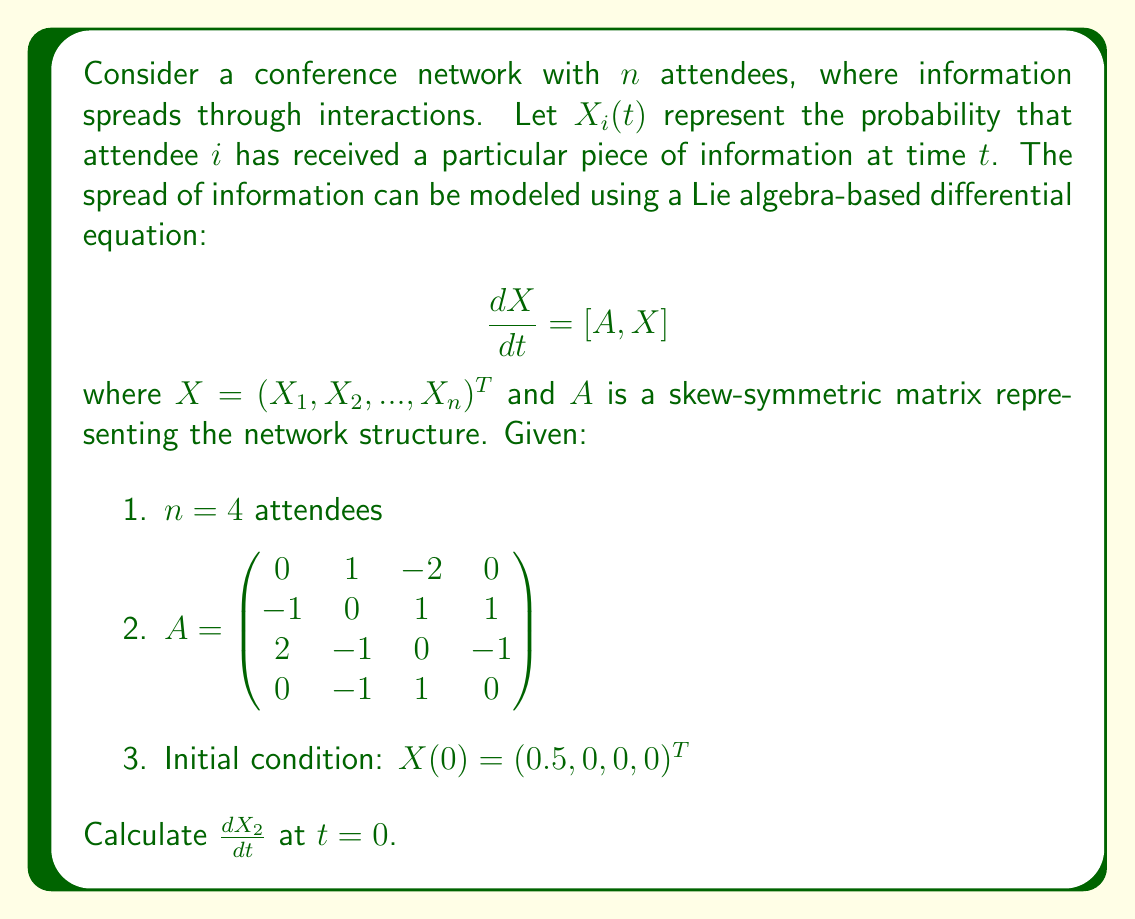Could you help me with this problem? To solve this problem, we need to follow these steps:

1) The Lie bracket $[A, X]$ is defined as the matrix commutator $AX - XA$. In our case, $X$ is a vector, so $XA$ is not defined. Therefore, $[A, X] = AX$.

2) We need to calculate $AX$ at $t = 0$:

   $$AX = \begin{pmatrix}
   0 & 1 & -2 & 0 \\
   -1 & 0 & 1 & 1 \\
   2 & -1 & 0 & -1 \\
   0 & -1 & 1 & 0
   \end{pmatrix} \begin{pmatrix}
   0.5 \\ 0 \\ 0 \\ 0
   \end{pmatrix}$$

3) Performing the matrix multiplication:

   $$AX = \begin{pmatrix}
   0(0.5) + 1(0) + (-2)(0) + 0(0) \\
   (-1)(0.5) + 0(0) + 1(0) + 1(0) \\
   2(0.5) + (-1)(0) + 0(0) + (-1)(0) \\
   0(0.5) + (-1)(0) + 1(0) + 0(0)
   \end{pmatrix} = \begin{pmatrix}
   0 \\ -0.5 \\ 1 \\ 0
   \end{pmatrix}$$

4) The result of this calculation gives us $\frac{dX}{dt}$ at $t = 0$.

5) The second component of this vector, $-0.5$, represents $\frac{dX_2}{dt}$ at $t = 0$.

Therefore, $\frac{dX_2}{dt}$ at $t = 0$ is $-0.5$.
Answer: $-0.5$ 